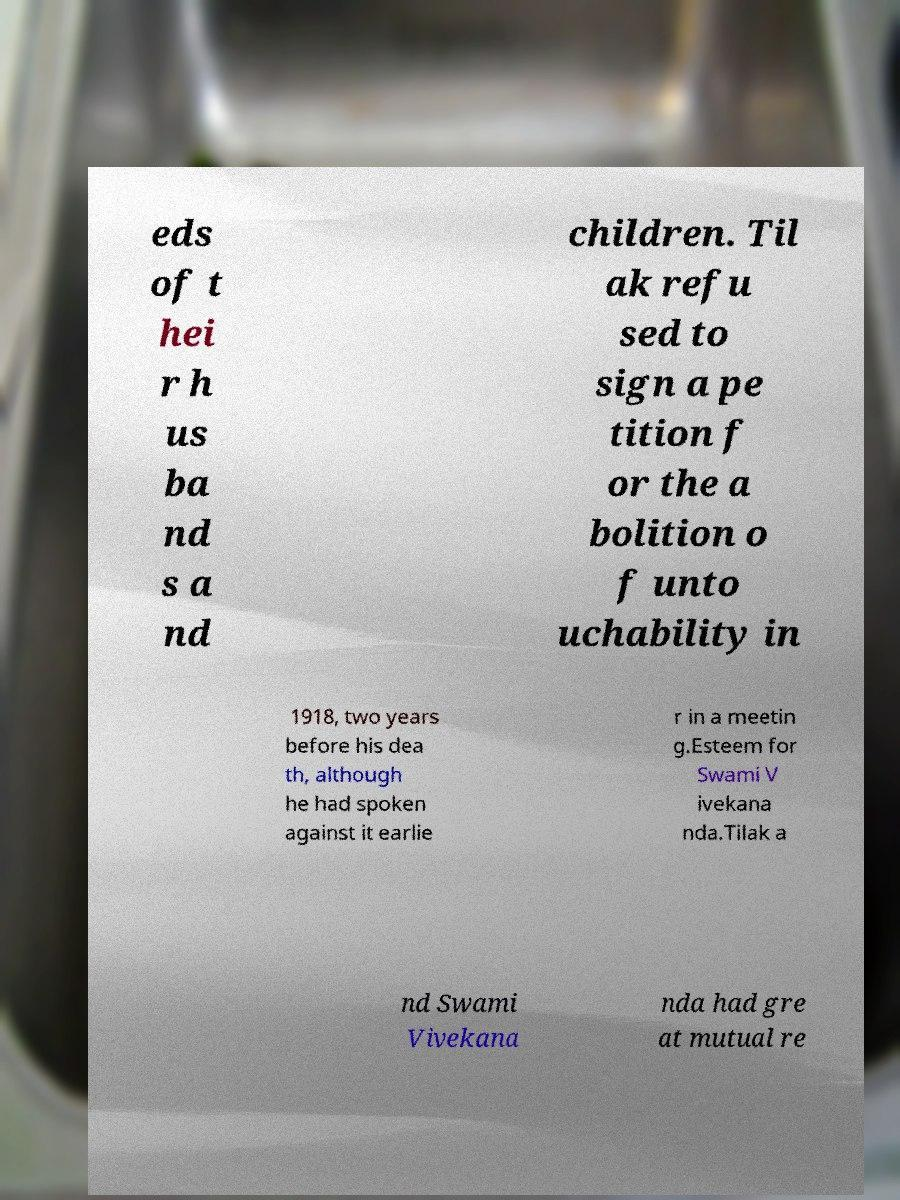Please identify and transcribe the text found in this image. eds of t hei r h us ba nd s a nd children. Til ak refu sed to sign a pe tition f or the a bolition o f unto uchability in 1918, two years before his dea th, although he had spoken against it earlie r in a meetin g.Esteem for Swami V ivekana nda.Tilak a nd Swami Vivekana nda had gre at mutual re 